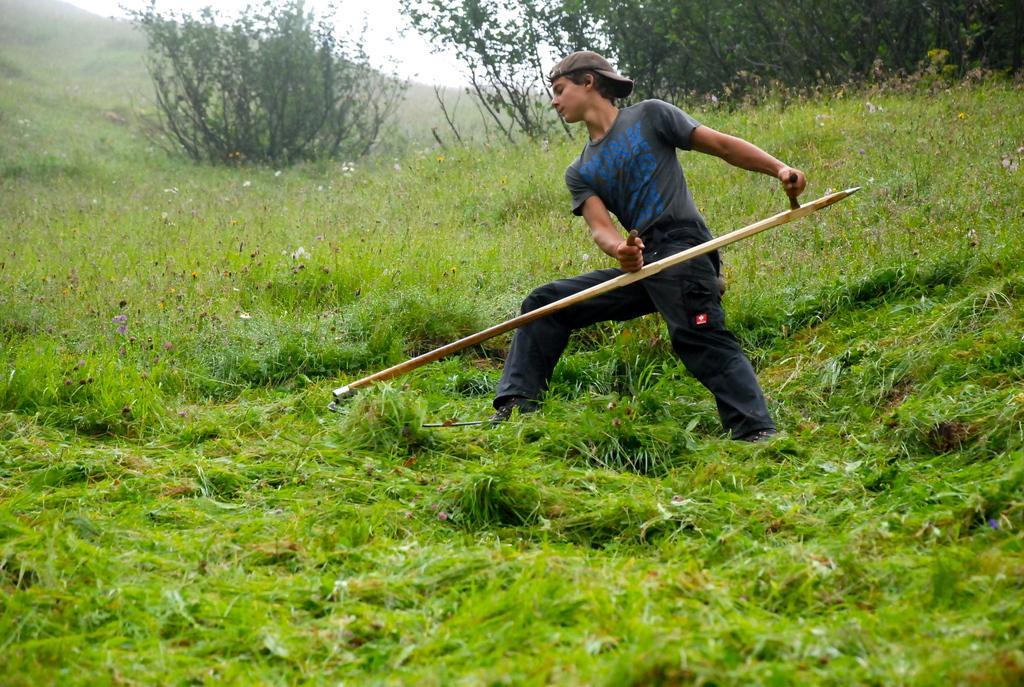Can you describe this image briefly? This image is taken outdoors. At the bottom of the image there is a ground with grass on it. In the background there is a hill and there are few plants with green leaves and stems. At the top of the sky. In the middle of the image a man is standing and he is holding a spade in his hands. 